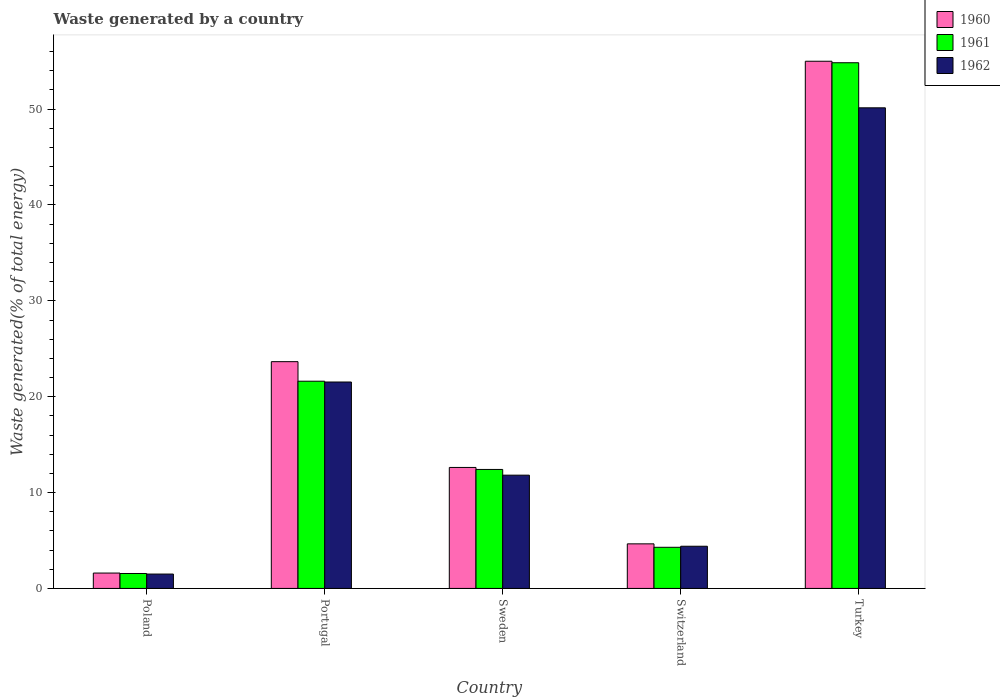How many groups of bars are there?
Provide a short and direct response. 5. Are the number of bars per tick equal to the number of legend labels?
Make the answer very short. Yes. What is the label of the 3rd group of bars from the left?
Offer a very short reply. Sweden. What is the total waste generated in 1960 in Switzerland?
Give a very brief answer. 4.65. Across all countries, what is the maximum total waste generated in 1960?
Make the answer very short. 54.99. Across all countries, what is the minimum total waste generated in 1962?
Ensure brevity in your answer.  1.5. In which country was the total waste generated in 1962 minimum?
Your answer should be compact. Poland. What is the total total waste generated in 1961 in the graph?
Offer a very short reply. 94.72. What is the difference between the total waste generated in 1962 in Switzerland and that in Turkey?
Offer a terse response. -45.73. What is the difference between the total waste generated in 1961 in Sweden and the total waste generated in 1960 in Poland?
Make the answer very short. 10.81. What is the average total waste generated in 1961 per country?
Your answer should be compact. 18.94. What is the difference between the total waste generated of/in 1962 and total waste generated of/in 1961 in Poland?
Offer a terse response. -0.06. What is the ratio of the total waste generated in 1961 in Poland to that in Turkey?
Your answer should be very brief. 0.03. Is the total waste generated in 1962 in Poland less than that in Portugal?
Offer a very short reply. Yes. What is the difference between the highest and the second highest total waste generated in 1961?
Keep it short and to the point. -9.2. What is the difference between the highest and the lowest total waste generated in 1960?
Ensure brevity in your answer.  53.39. What does the 2nd bar from the left in Poland represents?
Offer a terse response. 1961. What does the 2nd bar from the right in Portugal represents?
Provide a succinct answer. 1961. How many bars are there?
Make the answer very short. 15. Does the graph contain grids?
Provide a succinct answer. No. How many legend labels are there?
Give a very brief answer. 3. What is the title of the graph?
Your answer should be very brief. Waste generated by a country. Does "1984" appear as one of the legend labels in the graph?
Your answer should be very brief. No. What is the label or title of the Y-axis?
Provide a succinct answer. Waste generated(% of total energy). What is the Waste generated(% of total energy) in 1960 in Poland?
Keep it short and to the point. 1.6. What is the Waste generated(% of total energy) of 1961 in Poland?
Your answer should be very brief. 1.56. What is the Waste generated(% of total energy) of 1962 in Poland?
Your answer should be compact. 1.5. What is the Waste generated(% of total energy) in 1960 in Portugal?
Provide a short and direct response. 23.66. What is the Waste generated(% of total energy) of 1961 in Portugal?
Ensure brevity in your answer.  21.62. What is the Waste generated(% of total energy) of 1962 in Portugal?
Offer a very short reply. 21.53. What is the Waste generated(% of total energy) in 1960 in Sweden?
Your answer should be very brief. 12.62. What is the Waste generated(% of total energy) in 1961 in Sweden?
Your answer should be compact. 12.41. What is the Waste generated(% of total energy) in 1962 in Sweden?
Provide a succinct answer. 11.82. What is the Waste generated(% of total energy) in 1960 in Switzerland?
Make the answer very short. 4.65. What is the Waste generated(% of total energy) in 1961 in Switzerland?
Provide a short and direct response. 4.29. What is the Waste generated(% of total energy) of 1962 in Switzerland?
Keep it short and to the point. 4.4. What is the Waste generated(% of total energy) in 1960 in Turkey?
Offer a terse response. 54.99. What is the Waste generated(% of total energy) in 1961 in Turkey?
Ensure brevity in your answer.  54.84. What is the Waste generated(% of total energy) of 1962 in Turkey?
Ensure brevity in your answer.  50.13. Across all countries, what is the maximum Waste generated(% of total energy) in 1960?
Make the answer very short. 54.99. Across all countries, what is the maximum Waste generated(% of total energy) in 1961?
Offer a very short reply. 54.84. Across all countries, what is the maximum Waste generated(% of total energy) of 1962?
Offer a terse response. 50.13. Across all countries, what is the minimum Waste generated(% of total energy) in 1960?
Your answer should be compact. 1.6. Across all countries, what is the minimum Waste generated(% of total energy) in 1961?
Provide a short and direct response. 1.56. Across all countries, what is the minimum Waste generated(% of total energy) of 1962?
Keep it short and to the point. 1.5. What is the total Waste generated(% of total energy) in 1960 in the graph?
Make the answer very short. 97.53. What is the total Waste generated(% of total energy) of 1961 in the graph?
Ensure brevity in your answer.  94.72. What is the total Waste generated(% of total energy) of 1962 in the graph?
Your response must be concise. 89.39. What is the difference between the Waste generated(% of total energy) in 1960 in Poland and that in Portugal?
Ensure brevity in your answer.  -22.05. What is the difference between the Waste generated(% of total energy) in 1961 in Poland and that in Portugal?
Provide a short and direct response. -20.06. What is the difference between the Waste generated(% of total energy) in 1962 in Poland and that in Portugal?
Keep it short and to the point. -20.03. What is the difference between the Waste generated(% of total energy) of 1960 in Poland and that in Sweden?
Offer a terse response. -11.02. What is the difference between the Waste generated(% of total energy) in 1961 in Poland and that in Sweden?
Offer a terse response. -10.85. What is the difference between the Waste generated(% of total energy) in 1962 in Poland and that in Sweden?
Your response must be concise. -10.32. What is the difference between the Waste generated(% of total energy) in 1960 in Poland and that in Switzerland?
Your response must be concise. -3.04. What is the difference between the Waste generated(% of total energy) in 1961 in Poland and that in Switzerland?
Keep it short and to the point. -2.73. What is the difference between the Waste generated(% of total energy) of 1962 in Poland and that in Switzerland?
Your answer should be very brief. -2.9. What is the difference between the Waste generated(% of total energy) of 1960 in Poland and that in Turkey?
Offer a very short reply. -53.39. What is the difference between the Waste generated(% of total energy) in 1961 in Poland and that in Turkey?
Your answer should be compact. -53.28. What is the difference between the Waste generated(% of total energy) of 1962 in Poland and that in Turkey?
Offer a very short reply. -48.64. What is the difference between the Waste generated(% of total energy) in 1960 in Portugal and that in Sweden?
Give a very brief answer. 11.03. What is the difference between the Waste generated(% of total energy) of 1961 in Portugal and that in Sweden?
Your answer should be compact. 9.2. What is the difference between the Waste generated(% of total energy) of 1962 in Portugal and that in Sweden?
Offer a very short reply. 9.72. What is the difference between the Waste generated(% of total energy) in 1960 in Portugal and that in Switzerland?
Offer a very short reply. 19.01. What is the difference between the Waste generated(% of total energy) in 1961 in Portugal and that in Switzerland?
Your answer should be very brief. 17.32. What is the difference between the Waste generated(% of total energy) in 1962 in Portugal and that in Switzerland?
Provide a short and direct response. 17.13. What is the difference between the Waste generated(% of total energy) of 1960 in Portugal and that in Turkey?
Your answer should be very brief. -31.34. What is the difference between the Waste generated(% of total energy) in 1961 in Portugal and that in Turkey?
Provide a succinct answer. -33.22. What is the difference between the Waste generated(% of total energy) in 1962 in Portugal and that in Turkey?
Your answer should be very brief. -28.6. What is the difference between the Waste generated(% of total energy) of 1960 in Sweden and that in Switzerland?
Your response must be concise. 7.97. What is the difference between the Waste generated(% of total energy) of 1961 in Sweden and that in Switzerland?
Provide a succinct answer. 8.12. What is the difference between the Waste generated(% of total energy) of 1962 in Sweden and that in Switzerland?
Your response must be concise. 7.41. What is the difference between the Waste generated(% of total energy) of 1960 in Sweden and that in Turkey?
Your answer should be compact. -42.37. What is the difference between the Waste generated(% of total energy) in 1961 in Sweden and that in Turkey?
Your answer should be compact. -42.43. What is the difference between the Waste generated(% of total energy) of 1962 in Sweden and that in Turkey?
Provide a succinct answer. -38.32. What is the difference between the Waste generated(% of total energy) in 1960 in Switzerland and that in Turkey?
Your response must be concise. -50.34. What is the difference between the Waste generated(% of total energy) in 1961 in Switzerland and that in Turkey?
Offer a very short reply. -50.55. What is the difference between the Waste generated(% of total energy) of 1962 in Switzerland and that in Turkey?
Give a very brief answer. -45.73. What is the difference between the Waste generated(% of total energy) in 1960 in Poland and the Waste generated(% of total energy) in 1961 in Portugal?
Offer a terse response. -20.01. What is the difference between the Waste generated(% of total energy) in 1960 in Poland and the Waste generated(% of total energy) in 1962 in Portugal?
Give a very brief answer. -19.93. What is the difference between the Waste generated(% of total energy) of 1961 in Poland and the Waste generated(% of total energy) of 1962 in Portugal?
Provide a succinct answer. -19.98. What is the difference between the Waste generated(% of total energy) in 1960 in Poland and the Waste generated(% of total energy) in 1961 in Sweden?
Make the answer very short. -10.81. What is the difference between the Waste generated(% of total energy) in 1960 in Poland and the Waste generated(% of total energy) in 1962 in Sweden?
Your answer should be compact. -10.21. What is the difference between the Waste generated(% of total energy) of 1961 in Poland and the Waste generated(% of total energy) of 1962 in Sweden?
Offer a terse response. -10.26. What is the difference between the Waste generated(% of total energy) in 1960 in Poland and the Waste generated(% of total energy) in 1961 in Switzerland?
Provide a succinct answer. -2.69. What is the difference between the Waste generated(% of total energy) in 1960 in Poland and the Waste generated(% of total energy) in 1962 in Switzerland?
Make the answer very short. -2.8. What is the difference between the Waste generated(% of total energy) in 1961 in Poland and the Waste generated(% of total energy) in 1962 in Switzerland?
Your answer should be compact. -2.84. What is the difference between the Waste generated(% of total energy) of 1960 in Poland and the Waste generated(% of total energy) of 1961 in Turkey?
Offer a very short reply. -53.23. What is the difference between the Waste generated(% of total energy) in 1960 in Poland and the Waste generated(% of total energy) in 1962 in Turkey?
Make the answer very short. -48.53. What is the difference between the Waste generated(% of total energy) of 1961 in Poland and the Waste generated(% of total energy) of 1962 in Turkey?
Ensure brevity in your answer.  -48.58. What is the difference between the Waste generated(% of total energy) of 1960 in Portugal and the Waste generated(% of total energy) of 1961 in Sweden?
Provide a succinct answer. 11.24. What is the difference between the Waste generated(% of total energy) in 1960 in Portugal and the Waste generated(% of total energy) in 1962 in Sweden?
Provide a short and direct response. 11.84. What is the difference between the Waste generated(% of total energy) in 1961 in Portugal and the Waste generated(% of total energy) in 1962 in Sweden?
Keep it short and to the point. 9.8. What is the difference between the Waste generated(% of total energy) of 1960 in Portugal and the Waste generated(% of total energy) of 1961 in Switzerland?
Offer a very short reply. 19.36. What is the difference between the Waste generated(% of total energy) of 1960 in Portugal and the Waste generated(% of total energy) of 1962 in Switzerland?
Your answer should be very brief. 19.25. What is the difference between the Waste generated(% of total energy) in 1961 in Portugal and the Waste generated(% of total energy) in 1962 in Switzerland?
Provide a succinct answer. 17.21. What is the difference between the Waste generated(% of total energy) of 1960 in Portugal and the Waste generated(% of total energy) of 1961 in Turkey?
Offer a very short reply. -31.18. What is the difference between the Waste generated(% of total energy) of 1960 in Portugal and the Waste generated(% of total energy) of 1962 in Turkey?
Keep it short and to the point. -26.48. What is the difference between the Waste generated(% of total energy) in 1961 in Portugal and the Waste generated(% of total energy) in 1962 in Turkey?
Offer a terse response. -28.52. What is the difference between the Waste generated(% of total energy) of 1960 in Sweden and the Waste generated(% of total energy) of 1961 in Switzerland?
Provide a succinct answer. 8.33. What is the difference between the Waste generated(% of total energy) in 1960 in Sweden and the Waste generated(% of total energy) in 1962 in Switzerland?
Your answer should be very brief. 8.22. What is the difference between the Waste generated(% of total energy) of 1961 in Sweden and the Waste generated(% of total energy) of 1962 in Switzerland?
Provide a short and direct response. 8.01. What is the difference between the Waste generated(% of total energy) of 1960 in Sweden and the Waste generated(% of total energy) of 1961 in Turkey?
Provide a short and direct response. -42.22. What is the difference between the Waste generated(% of total energy) in 1960 in Sweden and the Waste generated(% of total energy) in 1962 in Turkey?
Provide a succinct answer. -37.51. What is the difference between the Waste generated(% of total energy) of 1961 in Sweden and the Waste generated(% of total energy) of 1962 in Turkey?
Offer a terse response. -37.72. What is the difference between the Waste generated(% of total energy) of 1960 in Switzerland and the Waste generated(% of total energy) of 1961 in Turkey?
Provide a short and direct response. -50.19. What is the difference between the Waste generated(% of total energy) of 1960 in Switzerland and the Waste generated(% of total energy) of 1962 in Turkey?
Your response must be concise. -45.48. What is the difference between the Waste generated(% of total energy) of 1961 in Switzerland and the Waste generated(% of total energy) of 1962 in Turkey?
Offer a very short reply. -45.84. What is the average Waste generated(% of total energy) in 1960 per country?
Your response must be concise. 19.51. What is the average Waste generated(% of total energy) of 1961 per country?
Offer a terse response. 18.94. What is the average Waste generated(% of total energy) in 1962 per country?
Offer a terse response. 17.88. What is the difference between the Waste generated(% of total energy) in 1960 and Waste generated(% of total energy) in 1961 in Poland?
Your answer should be very brief. 0.05. What is the difference between the Waste generated(% of total energy) of 1960 and Waste generated(% of total energy) of 1962 in Poland?
Ensure brevity in your answer.  0.11. What is the difference between the Waste generated(% of total energy) of 1961 and Waste generated(% of total energy) of 1962 in Poland?
Offer a terse response. 0.06. What is the difference between the Waste generated(% of total energy) in 1960 and Waste generated(% of total energy) in 1961 in Portugal?
Provide a succinct answer. 2.04. What is the difference between the Waste generated(% of total energy) in 1960 and Waste generated(% of total energy) in 1962 in Portugal?
Provide a short and direct response. 2.12. What is the difference between the Waste generated(% of total energy) in 1961 and Waste generated(% of total energy) in 1962 in Portugal?
Make the answer very short. 0.08. What is the difference between the Waste generated(% of total energy) of 1960 and Waste generated(% of total energy) of 1961 in Sweden?
Provide a succinct answer. 0.21. What is the difference between the Waste generated(% of total energy) in 1960 and Waste generated(% of total energy) in 1962 in Sweden?
Keep it short and to the point. 0.81. What is the difference between the Waste generated(% of total energy) in 1961 and Waste generated(% of total energy) in 1962 in Sweden?
Keep it short and to the point. 0.6. What is the difference between the Waste generated(% of total energy) of 1960 and Waste generated(% of total energy) of 1961 in Switzerland?
Make the answer very short. 0.36. What is the difference between the Waste generated(% of total energy) of 1960 and Waste generated(% of total energy) of 1962 in Switzerland?
Make the answer very short. 0.25. What is the difference between the Waste generated(% of total energy) of 1961 and Waste generated(% of total energy) of 1962 in Switzerland?
Ensure brevity in your answer.  -0.11. What is the difference between the Waste generated(% of total energy) in 1960 and Waste generated(% of total energy) in 1961 in Turkey?
Your answer should be compact. 0.16. What is the difference between the Waste generated(% of total energy) of 1960 and Waste generated(% of total energy) of 1962 in Turkey?
Provide a short and direct response. 4.86. What is the difference between the Waste generated(% of total energy) in 1961 and Waste generated(% of total energy) in 1962 in Turkey?
Your response must be concise. 4.7. What is the ratio of the Waste generated(% of total energy) in 1960 in Poland to that in Portugal?
Provide a succinct answer. 0.07. What is the ratio of the Waste generated(% of total energy) in 1961 in Poland to that in Portugal?
Ensure brevity in your answer.  0.07. What is the ratio of the Waste generated(% of total energy) in 1962 in Poland to that in Portugal?
Provide a succinct answer. 0.07. What is the ratio of the Waste generated(% of total energy) of 1960 in Poland to that in Sweden?
Offer a very short reply. 0.13. What is the ratio of the Waste generated(% of total energy) of 1961 in Poland to that in Sweden?
Keep it short and to the point. 0.13. What is the ratio of the Waste generated(% of total energy) in 1962 in Poland to that in Sweden?
Provide a succinct answer. 0.13. What is the ratio of the Waste generated(% of total energy) of 1960 in Poland to that in Switzerland?
Keep it short and to the point. 0.35. What is the ratio of the Waste generated(% of total energy) in 1961 in Poland to that in Switzerland?
Make the answer very short. 0.36. What is the ratio of the Waste generated(% of total energy) in 1962 in Poland to that in Switzerland?
Offer a very short reply. 0.34. What is the ratio of the Waste generated(% of total energy) of 1960 in Poland to that in Turkey?
Provide a short and direct response. 0.03. What is the ratio of the Waste generated(% of total energy) in 1961 in Poland to that in Turkey?
Your response must be concise. 0.03. What is the ratio of the Waste generated(% of total energy) in 1962 in Poland to that in Turkey?
Provide a succinct answer. 0.03. What is the ratio of the Waste generated(% of total energy) of 1960 in Portugal to that in Sweden?
Offer a terse response. 1.87. What is the ratio of the Waste generated(% of total energy) in 1961 in Portugal to that in Sweden?
Your response must be concise. 1.74. What is the ratio of the Waste generated(% of total energy) in 1962 in Portugal to that in Sweden?
Keep it short and to the point. 1.82. What is the ratio of the Waste generated(% of total energy) in 1960 in Portugal to that in Switzerland?
Ensure brevity in your answer.  5.09. What is the ratio of the Waste generated(% of total energy) in 1961 in Portugal to that in Switzerland?
Keep it short and to the point. 5.04. What is the ratio of the Waste generated(% of total energy) in 1962 in Portugal to that in Switzerland?
Make the answer very short. 4.89. What is the ratio of the Waste generated(% of total energy) in 1960 in Portugal to that in Turkey?
Your response must be concise. 0.43. What is the ratio of the Waste generated(% of total energy) in 1961 in Portugal to that in Turkey?
Your response must be concise. 0.39. What is the ratio of the Waste generated(% of total energy) in 1962 in Portugal to that in Turkey?
Keep it short and to the point. 0.43. What is the ratio of the Waste generated(% of total energy) in 1960 in Sweden to that in Switzerland?
Keep it short and to the point. 2.71. What is the ratio of the Waste generated(% of total energy) of 1961 in Sweden to that in Switzerland?
Offer a very short reply. 2.89. What is the ratio of the Waste generated(% of total energy) in 1962 in Sweden to that in Switzerland?
Offer a very short reply. 2.68. What is the ratio of the Waste generated(% of total energy) in 1960 in Sweden to that in Turkey?
Provide a succinct answer. 0.23. What is the ratio of the Waste generated(% of total energy) of 1961 in Sweden to that in Turkey?
Give a very brief answer. 0.23. What is the ratio of the Waste generated(% of total energy) in 1962 in Sweden to that in Turkey?
Your answer should be compact. 0.24. What is the ratio of the Waste generated(% of total energy) of 1960 in Switzerland to that in Turkey?
Give a very brief answer. 0.08. What is the ratio of the Waste generated(% of total energy) in 1961 in Switzerland to that in Turkey?
Ensure brevity in your answer.  0.08. What is the ratio of the Waste generated(% of total energy) of 1962 in Switzerland to that in Turkey?
Your answer should be very brief. 0.09. What is the difference between the highest and the second highest Waste generated(% of total energy) in 1960?
Your response must be concise. 31.34. What is the difference between the highest and the second highest Waste generated(% of total energy) of 1961?
Offer a very short reply. 33.22. What is the difference between the highest and the second highest Waste generated(% of total energy) of 1962?
Keep it short and to the point. 28.6. What is the difference between the highest and the lowest Waste generated(% of total energy) in 1960?
Your answer should be very brief. 53.39. What is the difference between the highest and the lowest Waste generated(% of total energy) of 1961?
Offer a very short reply. 53.28. What is the difference between the highest and the lowest Waste generated(% of total energy) in 1962?
Your answer should be very brief. 48.64. 